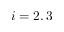<formula> <loc_0><loc_0><loc_500><loc_500>i = 2 , 3</formula> 